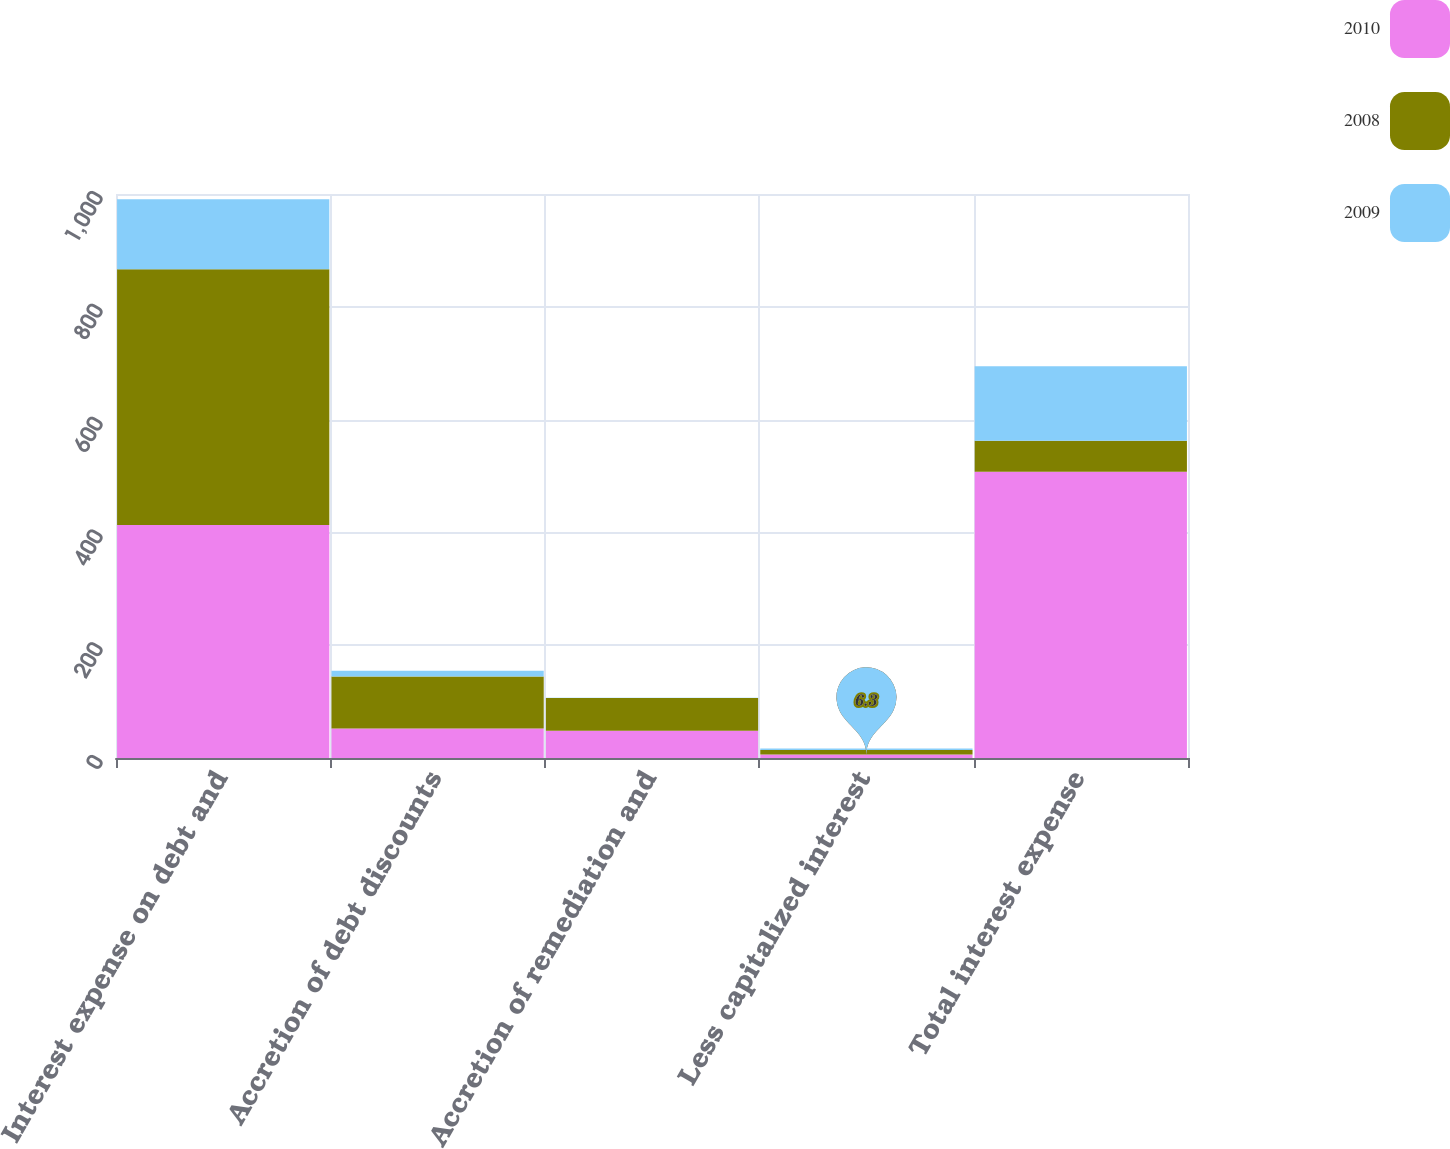Convert chart to OTSL. <chart><loc_0><loc_0><loc_500><loc_500><stacked_bar_chart><ecel><fcel>Interest expense on debt and<fcel>Accretion of debt discounts<fcel>Accretion of remediation and<fcel>Less capitalized interest<fcel>Total interest expense<nl><fcel>2010<fcel>413.2<fcel>52.4<fcel>48.1<fcel>6.3<fcel>507.4<nl><fcel>2008<fcel>453.5<fcel>92.1<fcel>58.1<fcel>7.8<fcel>55.25<nl><fcel>2009<fcel>123.9<fcel>10.1<fcel>0.5<fcel>2.6<fcel>131.9<nl></chart> 